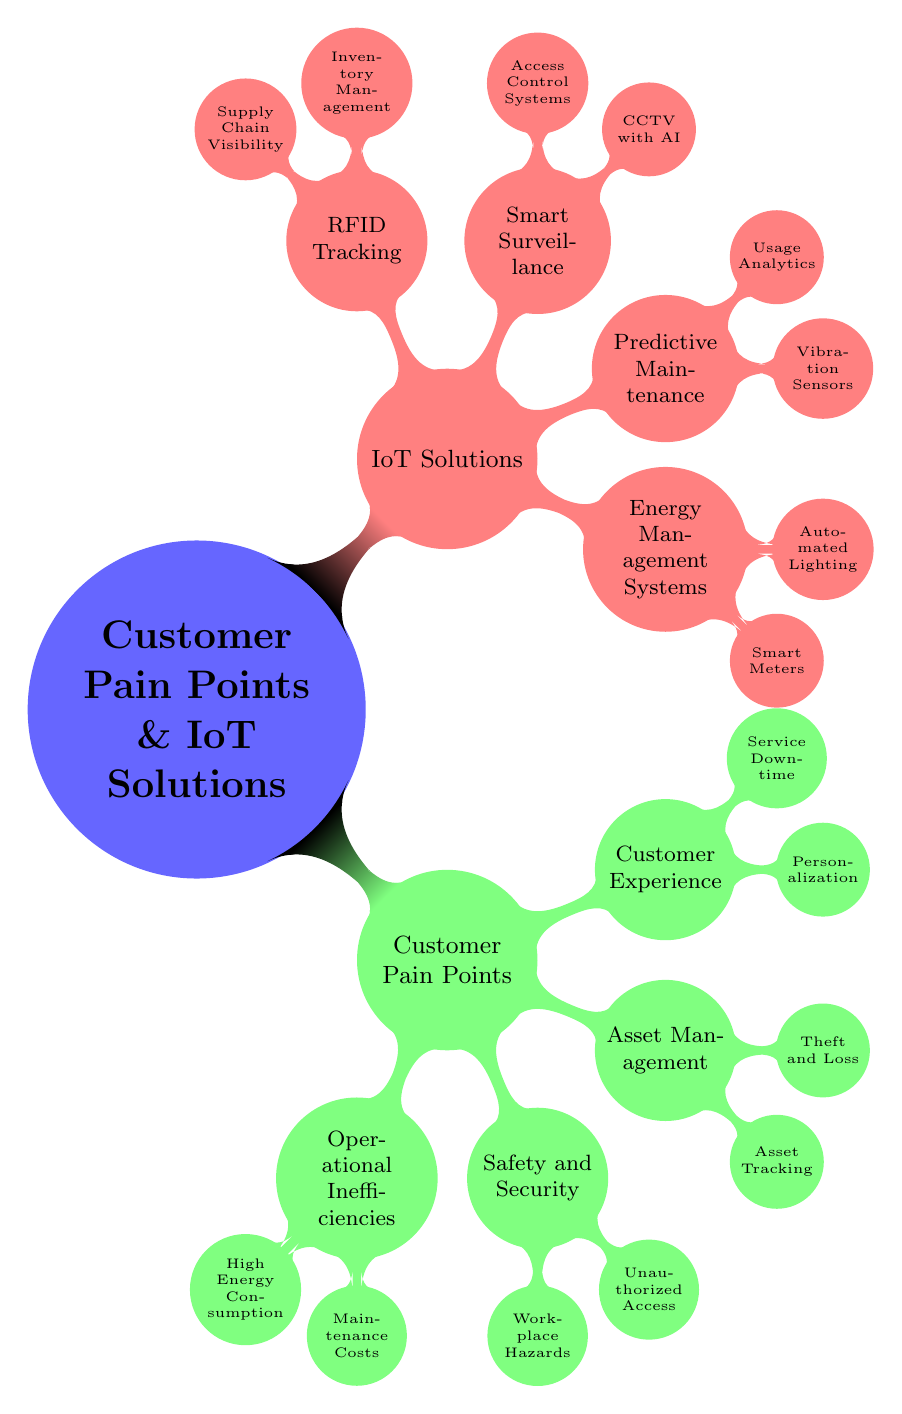What are the two main categories of the mind map? The mind map consists of two main categories: "Customer Pain Points" and "IoT Solutions". These categories branch out from the central node, clearly showing the primary focus areas covered in the diagram.
Answer: Customer Pain Points, IoT Solutions How many child nodes are under "Customer Pain Points"? The "Customer Pain Points" node has four child nodes: "Operational Inefficiencies," "Safety and Security," "Asset Management," and "Customer Experience." This is determined by counting the nodes directly connected to "Customer Pain Points."
Answer: 4 What IoT solution addresses "High Energy Consumption"? The IoT solution that specifically addresses "High Energy Consumption" is "Energy Management Systems." This is found by looking at the connection between the "High Energy Consumption" child under "Operational Inefficiencies" and the related IoT solution.
Answer: Energy Management Systems Which customer pain point has the solution "Wearable Safety Tech"? The customer pain point that corresponds to the solution "Wearable Safety Tech" is "Safety and Security". This is seen by tracing the relationship from the "Wearable Safety Tech" node under "IoT Solutions" back to the broader category of "Safety and Security."
Answer: Safety and Security How many specific types of solutions are listed under "Customer Experience"? Under "Customer Experience," there are two specific types of solutions listed: "Smart Retail Solutions" and "Remote Monitoring." This can be verified by counting the child nodes under the "Customer Experience" node.
Answer: 2 What is a common characteristic of the areas "Asset Tracking" and "Theft and Loss"? A common characteristic of both "Asset Tracking" and "Theft and Loss" is that they both fall under the category of "Asset Management." This shared categorization identifies the focus on managing and securing assets.
Answer: Asset Management Which type of solution utilizes "Vibration Sensors"? The type of solution that utilizes "Vibration Sensors" is "Predictive Maintenance." This is identified by following the connection from "Vibration Sensors" back to its parent node, "Predictive Maintenance."
Answer: Predictive Maintenance Which customer pain point includes "Unauthorized Access"? "Unauthorized Access" is included under the customer pain point of "Safety and Security." This is determined by locating the node "Unauthorized Access" and noting its parent category.
Answer: Safety and Security 